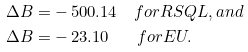Convert formula to latex. <formula><loc_0><loc_0><loc_500><loc_500>\Delta B = & - 5 0 0 . 1 4 \quad f o r R S Q L , a n d \\ \Delta B = & - 2 3 . 1 0 \quad \ \ f o r E U .</formula> 